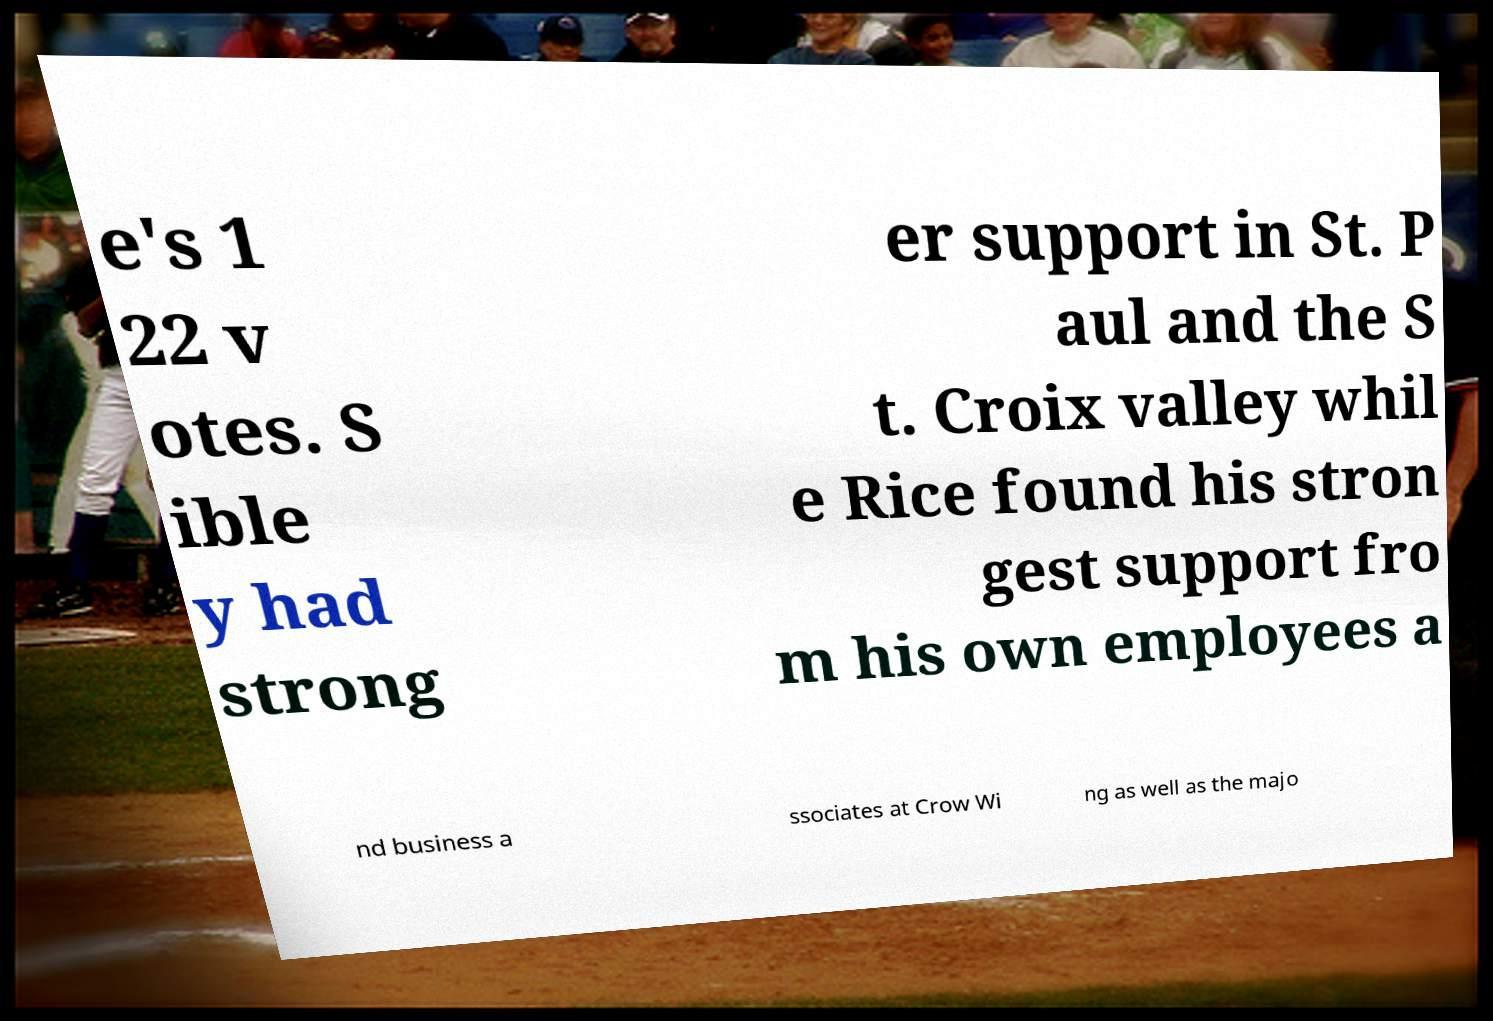Can you read and provide the text displayed in the image?This photo seems to have some interesting text. Can you extract and type it out for me? e's 1 22 v otes. S ible y had strong er support in St. P aul and the S t. Croix valley whil e Rice found his stron gest support fro m his own employees a nd business a ssociates at Crow Wi ng as well as the majo 